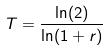<formula> <loc_0><loc_0><loc_500><loc_500>T = \frac { \ln ( 2 ) } { \ln ( 1 + r ) }</formula> 